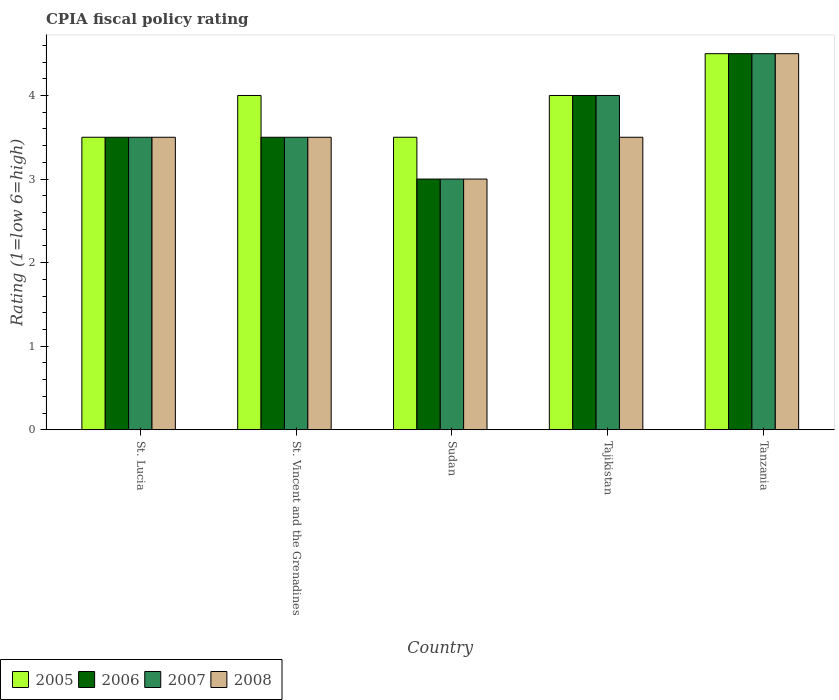How many different coloured bars are there?
Your answer should be very brief. 4. Are the number of bars per tick equal to the number of legend labels?
Give a very brief answer. Yes. How many bars are there on the 3rd tick from the left?
Ensure brevity in your answer.  4. What is the label of the 3rd group of bars from the left?
Ensure brevity in your answer.  Sudan. In how many cases, is the number of bars for a given country not equal to the number of legend labels?
Your answer should be very brief. 0. What is the CPIA rating in 2008 in Tanzania?
Offer a terse response. 4.5. Across all countries, what is the maximum CPIA rating in 2005?
Provide a short and direct response. 4.5. In which country was the CPIA rating in 2006 maximum?
Your answer should be very brief. Tanzania. In which country was the CPIA rating in 2006 minimum?
Give a very brief answer. Sudan. What is the total CPIA rating in 2007 in the graph?
Provide a short and direct response. 18.5. What is the difference between the CPIA rating in 2006 in St. Lucia and the CPIA rating in 2008 in Tajikistan?
Your answer should be compact. 0. What is the average CPIA rating in 2006 per country?
Keep it short and to the point. 3.7. What is the difference between the CPIA rating of/in 2008 and CPIA rating of/in 2006 in Sudan?
Offer a very short reply. 0. In how many countries, is the CPIA rating in 2006 greater than 1.2?
Your response must be concise. 5. What is the ratio of the CPIA rating in 2005 in St. Vincent and the Grenadines to that in Tajikistan?
Make the answer very short. 1. In how many countries, is the CPIA rating in 2008 greater than the average CPIA rating in 2008 taken over all countries?
Make the answer very short. 1. Is the sum of the CPIA rating in 2008 in St. Lucia and Tanzania greater than the maximum CPIA rating in 2006 across all countries?
Your answer should be very brief. Yes. What does the 2nd bar from the left in Tanzania represents?
Your response must be concise. 2006. Is it the case that in every country, the sum of the CPIA rating in 2006 and CPIA rating in 2005 is greater than the CPIA rating in 2007?
Offer a very short reply. Yes. How many bars are there?
Make the answer very short. 20. How many countries are there in the graph?
Offer a terse response. 5. Does the graph contain any zero values?
Your response must be concise. No. Does the graph contain grids?
Your answer should be compact. No. Where does the legend appear in the graph?
Provide a succinct answer. Bottom left. How many legend labels are there?
Give a very brief answer. 4. What is the title of the graph?
Your answer should be compact. CPIA fiscal policy rating. Does "1963" appear as one of the legend labels in the graph?
Offer a very short reply. No. What is the label or title of the X-axis?
Ensure brevity in your answer.  Country. What is the label or title of the Y-axis?
Provide a succinct answer. Rating (1=low 6=high). What is the Rating (1=low 6=high) of 2005 in St. Lucia?
Offer a terse response. 3.5. What is the Rating (1=low 6=high) of 2007 in St. Lucia?
Provide a short and direct response. 3.5. What is the Rating (1=low 6=high) of 2005 in St. Vincent and the Grenadines?
Your answer should be very brief. 4. What is the Rating (1=low 6=high) of 2006 in St. Vincent and the Grenadines?
Make the answer very short. 3.5. What is the Rating (1=low 6=high) of 2007 in St. Vincent and the Grenadines?
Ensure brevity in your answer.  3.5. What is the Rating (1=low 6=high) in 2005 in Sudan?
Your response must be concise. 3.5. What is the Rating (1=low 6=high) in 2007 in Sudan?
Your answer should be compact. 3. What is the Rating (1=low 6=high) of 2008 in Sudan?
Your answer should be very brief. 3. What is the Rating (1=low 6=high) of 2005 in Tajikistan?
Your response must be concise. 4. What is the Rating (1=low 6=high) of 2006 in Tajikistan?
Offer a terse response. 4. What is the Rating (1=low 6=high) of 2007 in Tajikistan?
Provide a short and direct response. 4. What is the Rating (1=low 6=high) of 2008 in Tajikistan?
Your answer should be very brief. 3.5. What is the Rating (1=low 6=high) in 2006 in Tanzania?
Ensure brevity in your answer.  4.5. What is the Rating (1=low 6=high) in 2007 in Tanzania?
Your response must be concise. 4.5. Across all countries, what is the minimum Rating (1=low 6=high) in 2005?
Keep it short and to the point. 3.5. Across all countries, what is the minimum Rating (1=low 6=high) of 2008?
Keep it short and to the point. 3. What is the total Rating (1=low 6=high) of 2005 in the graph?
Your answer should be very brief. 19.5. What is the total Rating (1=low 6=high) in 2007 in the graph?
Your answer should be very brief. 18.5. What is the difference between the Rating (1=low 6=high) of 2005 in St. Lucia and that in St. Vincent and the Grenadines?
Your answer should be compact. -0.5. What is the difference between the Rating (1=low 6=high) of 2006 in St. Lucia and that in St. Vincent and the Grenadines?
Keep it short and to the point. 0. What is the difference between the Rating (1=low 6=high) of 2008 in St. Lucia and that in St. Vincent and the Grenadines?
Give a very brief answer. 0. What is the difference between the Rating (1=low 6=high) in 2005 in St. Lucia and that in Tajikistan?
Give a very brief answer. -0.5. What is the difference between the Rating (1=low 6=high) in 2006 in St. Lucia and that in Tajikistan?
Ensure brevity in your answer.  -0.5. What is the difference between the Rating (1=low 6=high) in 2008 in St. Lucia and that in Tajikistan?
Your answer should be compact. 0. What is the difference between the Rating (1=low 6=high) in 2005 in St. Lucia and that in Tanzania?
Offer a terse response. -1. What is the difference between the Rating (1=low 6=high) in 2007 in St. Lucia and that in Tanzania?
Offer a terse response. -1. What is the difference between the Rating (1=low 6=high) of 2008 in St. Lucia and that in Tanzania?
Your response must be concise. -1. What is the difference between the Rating (1=low 6=high) of 2005 in St. Vincent and the Grenadines and that in Sudan?
Your answer should be very brief. 0.5. What is the difference between the Rating (1=low 6=high) in 2007 in St. Vincent and the Grenadines and that in Sudan?
Make the answer very short. 0.5. What is the difference between the Rating (1=low 6=high) of 2008 in St. Vincent and the Grenadines and that in Sudan?
Keep it short and to the point. 0.5. What is the difference between the Rating (1=low 6=high) in 2006 in St. Vincent and the Grenadines and that in Tajikistan?
Ensure brevity in your answer.  -0.5. What is the difference between the Rating (1=low 6=high) of 2007 in St. Vincent and the Grenadines and that in Tajikistan?
Offer a very short reply. -0.5. What is the difference between the Rating (1=low 6=high) in 2006 in St. Vincent and the Grenadines and that in Tanzania?
Ensure brevity in your answer.  -1. What is the difference between the Rating (1=low 6=high) in 2005 in Sudan and that in Tajikistan?
Provide a succinct answer. -0.5. What is the difference between the Rating (1=low 6=high) of 2006 in Sudan and that in Tajikistan?
Keep it short and to the point. -1. What is the difference between the Rating (1=low 6=high) in 2005 in Sudan and that in Tanzania?
Keep it short and to the point. -1. What is the difference between the Rating (1=low 6=high) in 2006 in Sudan and that in Tanzania?
Provide a short and direct response. -1.5. What is the difference between the Rating (1=low 6=high) in 2007 in Sudan and that in Tanzania?
Provide a short and direct response. -1.5. What is the difference between the Rating (1=low 6=high) in 2006 in Tajikistan and that in Tanzania?
Provide a short and direct response. -0.5. What is the difference between the Rating (1=low 6=high) in 2005 in St. Lucia and the Rating (1=low 6=high) in 2008 in St. Vincent and the Grenadines?
Your answer should be very brief. 0. What is the difference between the Rating (1=low 6=high) in 2006 in St. Lucia and the Rating (1=low 6=high) in 2007 in St. Vincent and the Grenadines?
Provide a succinct answer. 0. What is the difference between the Rating (1=low 6=high) of 2006 in St. Lucia and the Rating (1=low 6=high) of 2008 in St. Vincent and the Grenadines?
Keep it short and to the point. 0. What is the difference between the Rating (1=low 6=high) in 2007 in St. Lucia and the Rating (1=low 6=high) in 2008 in St. Vincent and the Grenadines?
Give a very brief answer. 0. What is the difference between the Rating (1=low 6=high) of 2005 in St. Lucia and the Rating (1=low 6=high) of 2007 in Sudan?
Your response must be concise. 0.5. What is the difference between the Rating (1=low 6=high) in 2006 in St. Lucia and the Rating (1=low 6=high) in 2007 in Sudan?
Offer a terse response. 0.5. What is the difference between the Rating (1=low 6=high) in 2007 in St. Lucia and the Rating (1=low 6=high) in 2008 in Sudan?
Provide a succinct answer. 0.5. What is the difference between the Rating (1=low 6=high) of 2005 in St. Lucia and the Rating (1=low 6=high) of 2006 in Tajikistan?
Offer a very short reply. -0.5. What is the difference between the Rating (1=low 6=high) in 2005 in St. Lucia and the Rating (1=low 6=high) in 2008 in Tajikistan?
Provide a short and direct response. 0. What is the difference between the Rating (1=low 6=high) in 2005 in St. Lucia and the Rating (1=low 6=high) in 2007 in Tanzania?
Offer a very short reply. -1. What is the difference between the Rating (1=low 6=high) in 2005 in St. Lucia and the Rating (1=low 6=high) in 2008 in Tanzania?
Offer a very short reply. -1. What is the difference between the Rating (1=low 6=high) of 2006 in St. Lucia and the Rating (1=low 6=high) of 2007 in Tanzania?
Your answer should be very brief. -1. What is the difference between the Rating (1=low 6=high) in 2006 in St. Lucia and the Rating (1=low 6=high) in 2008 in Tanzania?
Provide a short and direct response. -1. What is the difference between the Rating (1=low 6=high) of 2005 in St. Vincent and the Grenadines and the Rating (1=low 6=high) of 2006 in Sudan?
Provide a short and direct response. 1. What is the difference between the Rating (1=low 6=high) of 2006 in St. Vincent and the Grenadines and the Rating (1=low 6=high) of 2007 in Sudan?
Your answer should be very brief. 0.5. What is the difference between the Rating (1=low 6=high) of 2005 in St. Vincent and the Grenadines and the Rating (1=low 6=high) of 2006 in Tajikistan?
Offer a very short reply. 0. What is the difference between the Rating (1=low 6=high) of 2007 in St. Vincent and the Grenadines and the Rating (1=low 6=high) of 2008 in Tajikistan?
Offer a very short reply. 0. What is the difference between the Rating (1=low 6=high) of 2005 in St. Vincent and the Grenadines and the Rating (1=low 6=high) of 2008 in Tanzania?
Keep it short and to the point. -0.5. What is the difference between the Rating (1=low 6=high) in 2006 in St. Vincent and the Grenadines and the Rating (1=low 6=high) in 2008 in Tanzania?
Ensure brevity in your answer.  -1. What is the difference between the Rating (1=low 6=high) of 2005 in Sudan and the Rating (1=low 6=high) of 2007 in Tajikistan?
Your response must be concise. -0.5. What is the difference between the Rating (1=low 6=high) of 2006 in Sudan and the Rating (1=low 6=high) of 2007 in Tajikistan?
Provide a succinct answer. -1. What is the difference between the Rating (1=low 6=high) in 2007 in Sudan and the Rating (1=low 6=high) in 2008 in Tajikistan?
Provide a succinct answer. -0.5. What is the difference between the Rating (1=low 6=high) in 2005 in Sudan and the Rating (1=low 6=high) in 2006 in Tanzania?
Ensure brevity in your answer.  -1. What is the difference between the Rating (1=low 6=high) in 2005 in Sudan and the Rating (1=low 6=high) in 2007 in Tanzania?
Provide a succinct answer. -1. What is the difference between the Rating (1=low 6=high) of 2005 in Sudan and the Rating (1=low 6=high) of 2008 in Tanzania?
Provide a succinct answer. -1. What is the difference between the Rating (1=low 6=high) in 2006 in Sudan and the Rating (1=low 6=high) in 2007 in Tanzania?
Your answer should be very brief. -1.5. What is the difference between the Rating (1=low 6=high) in 2006 in Sudan and the Rating (1=low 6=high) in 2008 in Tanzania?
Offer a terse response. -1.5. What is the difference between the Rating (1=low 6=high) of 2007 in Sudan and the Rating (1=low 6=high) of 2008 in Tanzania?
Your response must be concise. -1.5. What is the difference between the Rating (1=low 6=high) in 2006 in Tajikistan and the Rating (1=low 6=high) in 2008 in Tanzania?
Offer a terse response. -0.5. What is the difference between the Rating (1=low 6=high) of 2007 in Tajikistan and the Rating (1=low 6=high) of 2008 in Tanzania?
Keep it short and to the point. -0.5. What is the average Rating (1=low 6=high) in 2006 per country?
Offer a terse response. 3.7. What is the average Rating (1=low 6=high) of 2008 per country?
Make the answer very short. 3.6. What is the difference between the Rating (1=low 6=high) in 2005 and Rating (1=low 6=high) in 2006 in St. Lucia?
Make the answer very short. 0. What is the difference between the Rating (1=low 6=high) in 2005 and Rating (1=low 6=high) in 2008 in St. Lucia?
Make the answer very short. 0. What is the difference between the Rating (1=low 6=high) in 2007 and Rating (1=low 6=high) in 2008 in St. Lucia?
Give a very brief answer. 0. What is the difference between the Rating (1=low 6=high) of 2005 and Rating (1=low 6=high) of 2008 in St. Vincent and the Grenadines?
Offer a very short reply. 0.5. What is the difference between the Rating (1=low 6=high) of 2006 and Rating (1=low 6=high) of 2007 in St. Vincent and the Grenadines?
Offer a terse response. 0. What is the difference between the Rating (1=low 6=high) in 2006 and Rating (1=low 6=high) in 2008 in St. Vincent and the Grenadines?
Make the answer very short. 0. What is the difference between the Rating (1=low 6=high) in 2005 and Rating (1=low 6=high) in 2006 in Sudan?
Offer a terse response. 0.5. What is the difference between the Rating (1=low 6=high) of 2005 and Rating (1=low 6=high) of 2008 in Sudan?
Provide a short and direct response. 0.5. What is the difference between the Rating (1=low 6=high) in 2007 and Rating (1=low 6=high) in 2008 in Sudan?
Your answer should be compact. 0. What is the difference between the Rating (1=low 6=high) in 2005 and Rating (1=low 6=high) in 2006 in Tajikistan?
Keep it short and to the point. 0. What is the difference between the Rating (1=low 6=high) in 2005 and Rating (1=low 6=high) in 2008 in Tajikistan?
Keep it short and to the point. 0.5. What is the difference between the Rating (1=low 6=high) in 2006 and Rating (1=low 6=high) in 2007 in Tajikistan?
Your answer should be very brief. 0. What is the difference between the Rating (1=low 6=high) in 2006 and Rating (1=low 6=high) in 2008 in Tajikistan?
Your answer should be compact. 0.5. What is the difference between the Rating (1=low 6=high) of 2007 and Rating (1=low 6=high) of 2008 in Tajikistan?
Ensure brevity in your answer.  0.5. What is the difference between the Rating (1=low 6=high) in 2005 and Rating (1=low 6=high) in 2006 in Tanzania?
Offer a terse response. 0. What is the difference between the Rating (1=low 6=high) of 2005 and Rating (1=low 6=high) of 2007 in Tanzania?
Make the answer very short. 0. What is the difference between the Rating (1=low 6=high) of 2005 and Rating (1=low 6=high) of 2008 in Tanzania?
Offer a very short reply. 0. What is the difference between the Rating (1=low 6=high) of 2006 and Rating (1=low 6=high) of 2007 in Tanzania?
Provide a short and direct response. 0. What is the ratio of the Rating (1=low 6=high) in 2005 in St. Lucia to that in St. Vincent and the Grenadines?
Offer a very short reply. 0.88. What is the ratio of the Rating (1=low 6=high) in 2007 in St. Lucia to that in St. Vincent and the Grenadines?
Offer a very short reply. 1. What is the ratio of the Rating (1=low 6=high) of 2008 in St. Lucia to that in St. Vincent and the Grenadines?
Provide a succinct answer. 1. What is the ratio of the Rating (1=low 6=high) of 2005 in St. Lucia to that in Sudan?
Ensure brevity in your answer.  1. What is the ratio of the Rating (1=low 6=high) of 2006 in St. Lucia to that in Sudan?
Provide a short and direct response. 1.17. What is the ratio of the Rating (1=low 6=high) of 2008 in St. Lucia to that in Sudan?
Make the answer very short. 1.17. What is the ratio of the Rating (1=low 6=high) in 2008 in St. Lucia to that in Tanzania?
Your answer should be compact. 0.78. What is the ratio of the Rating (1=low 6=high) of 2006 in St. Vincent and the Grenadines to that in Sudan?
Your answer should be very brief. 1.17. What is the ratio of the Rating (1=low 6=high) in 2006 in St. Vincent and the Grenadines to that in Tajikistan?
Make the answer very short. 0.88. What is the ratio of the Rating (1=low 6=high) of 2005 in St. Vincent and the Grenadines to that in Tanzania?
Your response must be concise. 0.89. What is the ratio of the Rating (1=low 6=high) in 2007 in St. Vincent and the Grenadines to that in Tanzania?
Your response must be concise. 0.78. What is the ratio of the Rating (1=low 6=high) of 2008 in St. Vincent and the Grenadines to that in Tanzania?
Ensure brevity in your answer.  0.78. What is the ratio of the Rating (1=low 6=high) of 2007 in Sudan to that in Tajikistan?
Your answer should be very brief. 0.75. What is the ratio of the Rating (1=low 6=high) of 2008 in Sudan to that in Tajikistan?
Offer a very short reply. 0.86. What is the ratio of the Rating (1=low 6=high) in 2005 in Sudan to that in Tanzania?
Offer a terse response. 0.78. What is the ratio of the Rating (1=low 6=high) of 2007 in Sudan to that in Tanzania?
Make the answer very short. 0.67. What is the ratio of the Rating (1=low 6=high) in 2006 in Tajikistan to that in Tanzania?
Provide a short and direct response. 0.89. What is the ratio of the Rating (1=low 6=high) in 2007 in Tajikistan to that in Tanzania?
Keep it short and to the point. 0.89. What is the difference between the highest and the second highest Rating (1=low 6=high) in 2006?
Ensure brevity in your answer.  0.5. What is the difference between the highest and the lowest Rating (1=low 6=high) of 2006?
Offer a very short reply. 1.5. What is the difference between the highest and the lowest Rating (1=low 6=high) of 2007?
Provide a succinct answer. 1.5. What is the difference between the highest and the lowest Rating (1=low 6=high) in 2008?
Your answer should be compact. 1.5. 